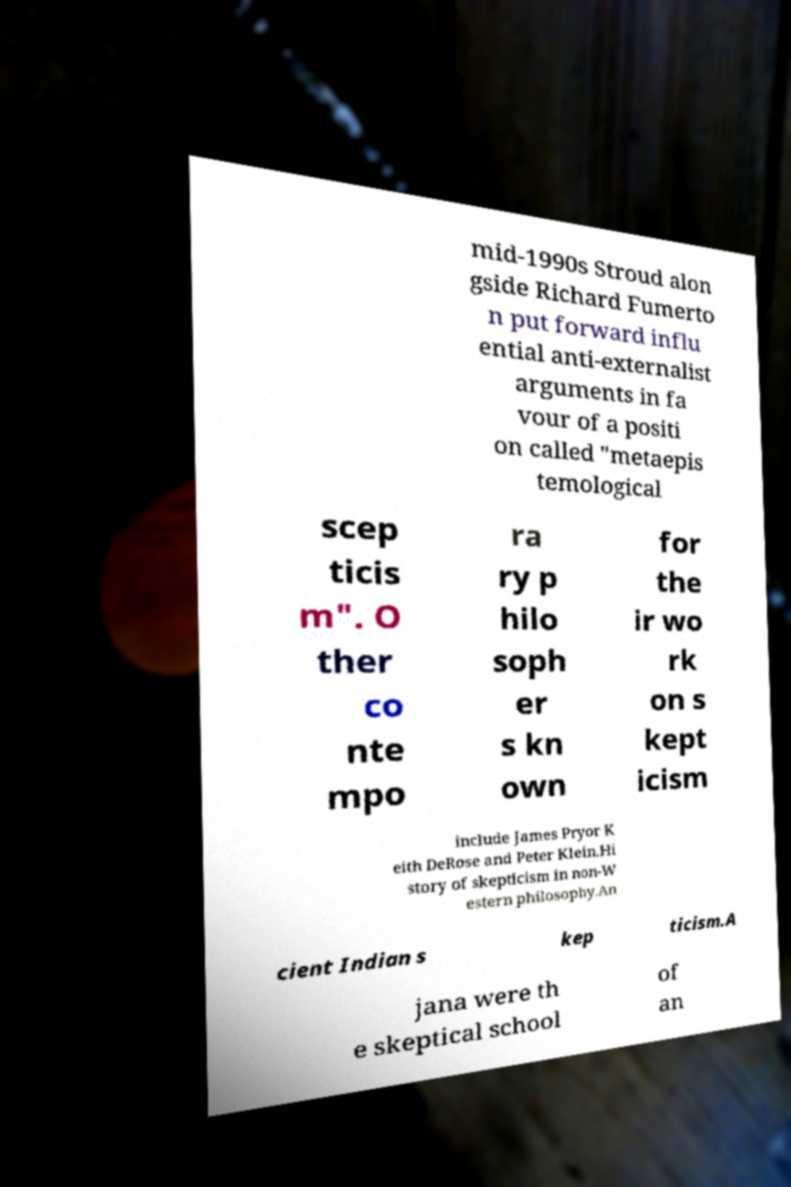Please read and relay the text visible in this image. What does it say? mid-1990s Stroud alon gside Richard Fumerto n put forward influ ential anti-externalist arguments in fa vour of a positi on called "metaepis temological scep ticis m". O ther co nte mpo ra ry p hilo soph er s kn own for the ir wo rk on s kept icism include James Pryor K eith DeRose and Peter Klein.Hi story of skepticism in non-W estern philosophy.An cient Indian s kep ticism.A jana were th e skeptical school of an 